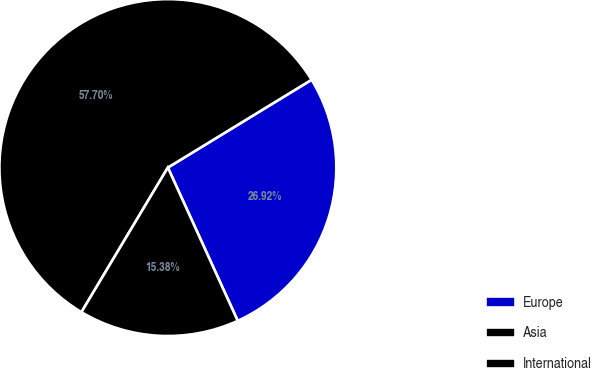Convert chart to OTSL. <chart><loc_0><loc_0><loc_500><loc_500><pie_chart><fcel>Europe<fcel>Asia<fcel>International<nl><fcel>26.92%<fcel>57.69%<fcel>15.38%<nl></chart> 